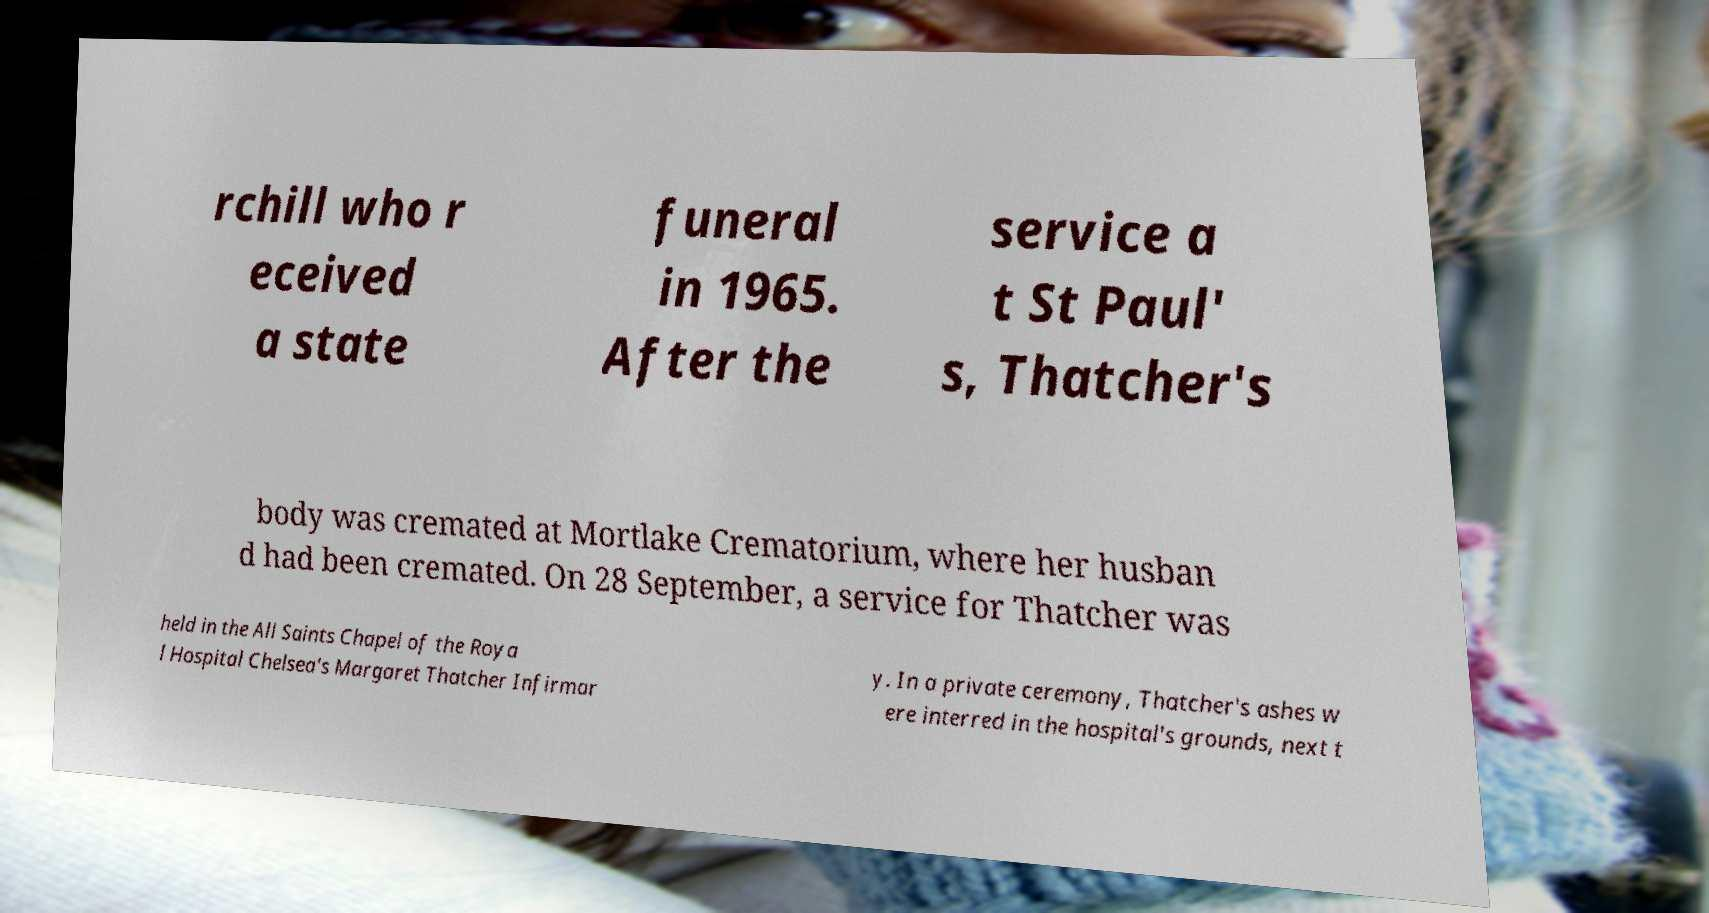I need the written content from this picture converted into text. Can you do that? rchill who r eceived a state funeral in 1965. After the service a t St Paul' s, Thatcher's body was cremated at Mortlake Crematorium, where her husban d had been cremated. On 28 September, a service for Thatcher was held in the All Saints Chapel of the Roya l Hospital Chelsea's Margaret Thatcher Infirmar y. In a private ceremony, Thatcher's ashes w ere interred in the hospital's grounds, next t 